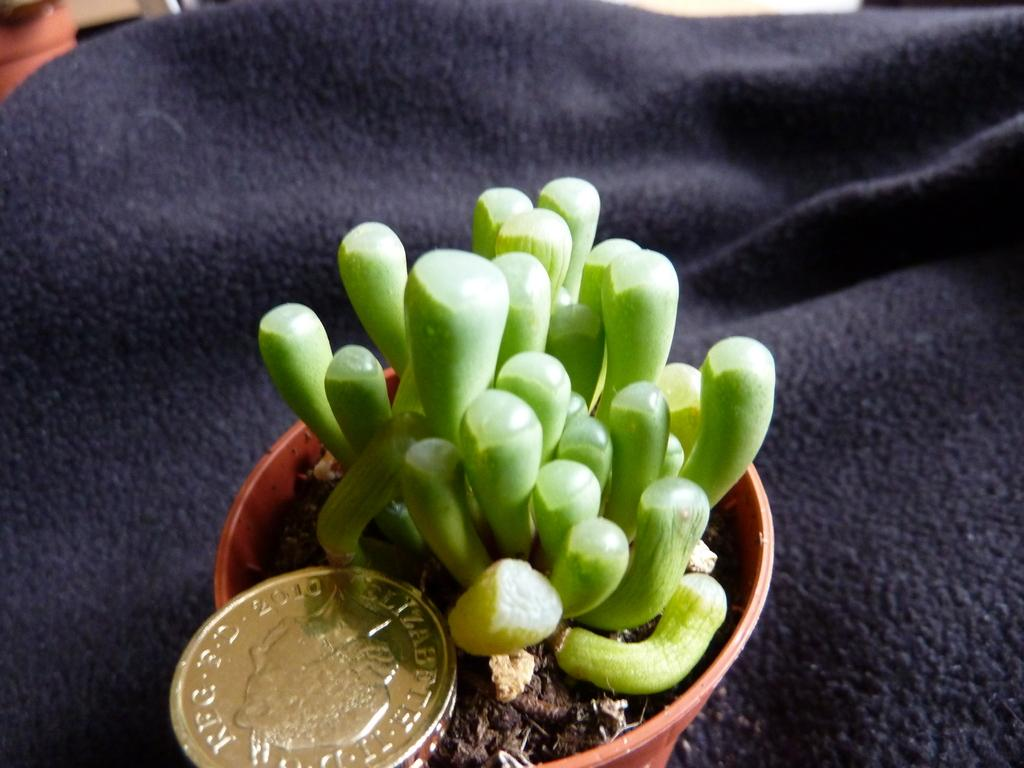What can be seen in the picture related to plants? There is a plant pot in the picture. What is the small, round object in the picture? There is a coin in the picture. What item in the picture resembles a covering or wrap? There is an object that resembles a blanket in the picture. How much rice is being cooked in the picture? There is no rice present in the image. What is the income of the person in the picture? There is no person in the picture, so income cannot be determined. 